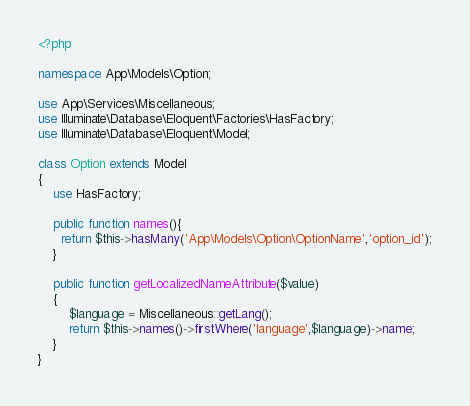<code> <loc_0><loc_0><loc_500><loc_500><_PHP_><?php

namespace App\Models\Option;

use App\Services\Miscellaneous;
use Illuminate\Database\Eloquent\Factories\HasFactory;
use Illuminate\Database\Eloquent\Model;

class Option extends Model
{
    use HasFactory;

    public function names(){
      return $this->hasMany('App\Models\Option\OptionName','option_id');
    }

    public function getLocalizedNameAttribute($value)
    {
        $language = Miscellaneous::getLang();
        return $this->names()->firstWhere('language',$language)->name;
    }
}
</code> 